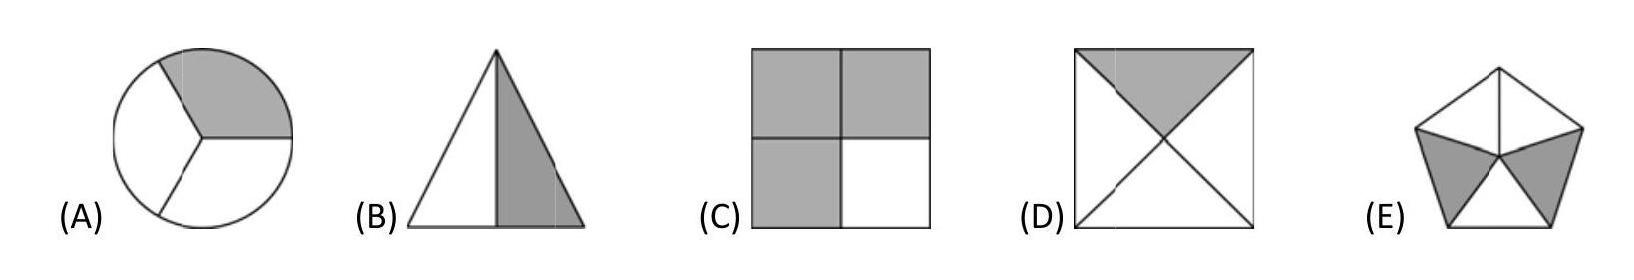Can you explain why none of the other shapes fit the criteria of having one half grey? Certainly! In shape A, less than half of the circle is grey. Shape C is divided into four equal parts, each a quarter, so no half portion is grey. Shape D also has divisions, with each segment being less than half. Lastly, shape E shows multiple triangular segments with grey areas, but none constituting exactly half. 